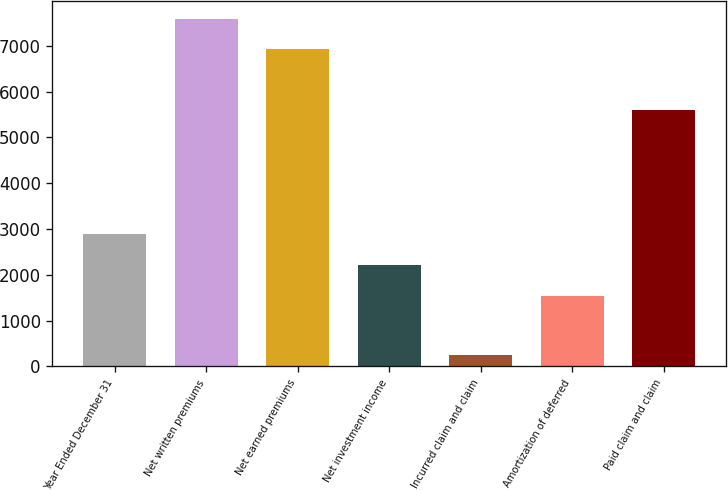<chart> <loc_0><loc_0><loc_500><loc_500><bar_chart><fcel>Year Ended December 31<fcel>Net written premiums<fcel>Net earned premiums<fcel>Net investment income<fcel>Incurred claim and claim<fcel>Amortization of deferred<fcel>Paid claim and claim<nl><fcel>2881.4<fcel>7591.7<fcel>6921<fcel>2210.7<fcel>255<fcel>1540<fcel>5604.7<nl></chart> 